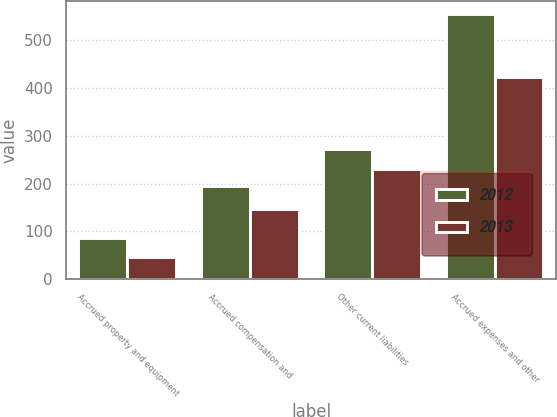Convert chart. <chart><loc_0><loc_0><loc_500><loc_500><stacked_bar_chart><ecel><fcel>Accrued property and equipment<fcel>Accrued compensation and<fcel>Other current liabilities<fcel>Accrued expenses and other<nl><fcel>2012<fcel>87<fcel>196<fcel>272<fcel>555<nl><fcel>2013<fcel>46<fcel>146<fcel>231<fcel>423<nl></chart> 